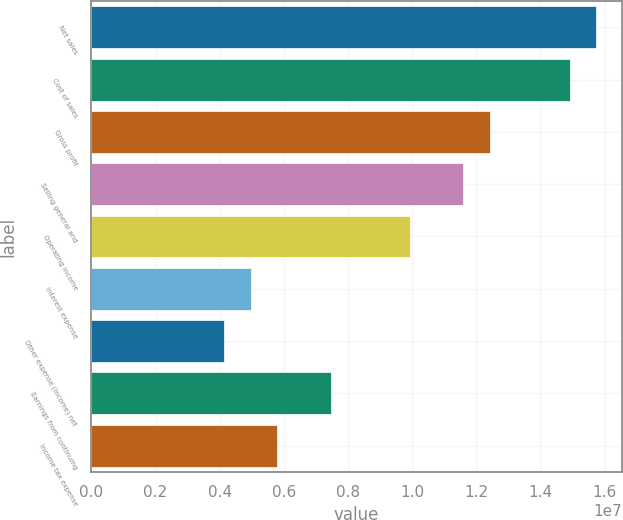Convert chart. <chart><loc_0><loc_0><loc_500><loc_500><bar_chart><fcel>Net sales<fcel>Cost of sales<fcel>Gross profit<fcel>Selling general and<fcel>Operating income<fcel>Interest expense<fcel>Other expense (income) net<fcel>Earnings from continuing<fcel>Income tax expense<nl><fcel>1.57425e+07<fcel>1.4914e+07<fcel>1.24283e+07<fcel>1.15998e+07<fcel>9.94265e+06<fcel>4.97133e+06<fcel>4.14278e+06<fcel>7.45699e+06<fcel>5.79988e+06<nl></chart> 